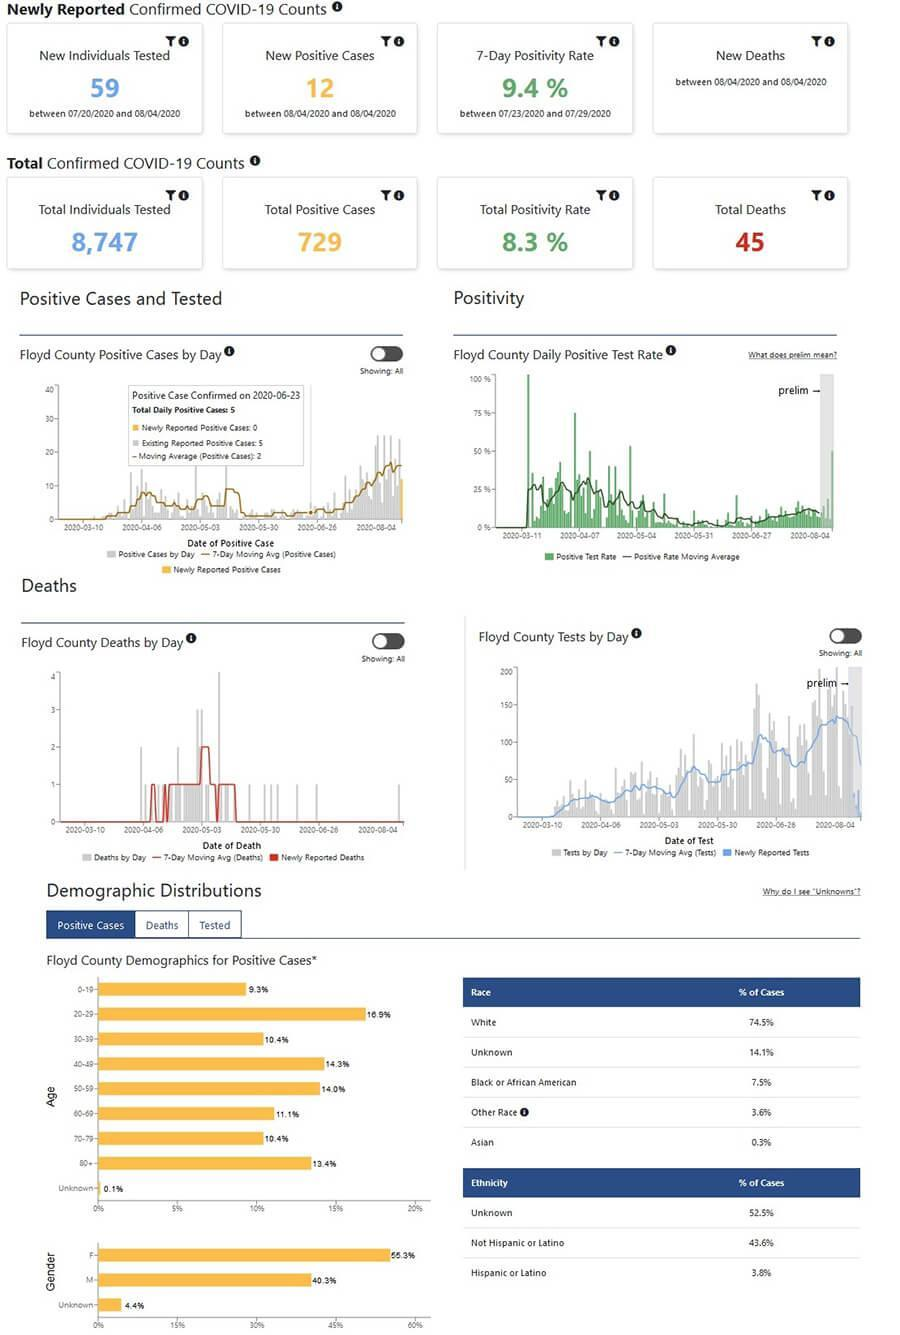What is the percentage of covid-19 infected below 40?
Answer the question with a short phrase. 36.6 What is the percentage of covid-19 infected between the age group 0-29? 26.2% What is the percentage of covid-19 infected between the age group 20-49? 41.6% which age group the most number of infected people belong to? 20-29 What is the percentage of covid-19 infected between the age group 40-59? 28.3 What is the percentage of covid-19 infected above 60? 34.9% which age group the least number of infected people belong to? 0-9 What is the percentage of covid-19 infected above 70? 23.8 which age group the most number of infected people belong to? female What is the percentage of covid-19 infected people from white and Asian race combined? 74.8% 